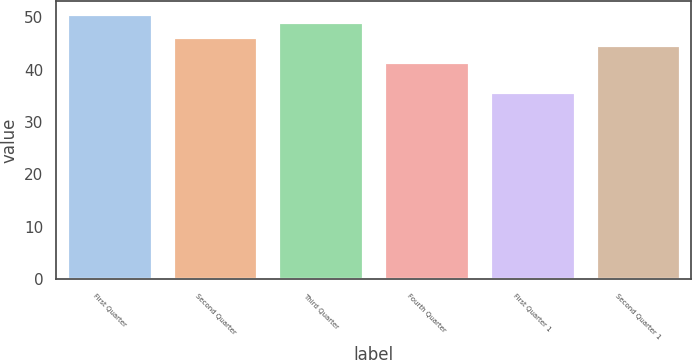Convert chart to OTSL. <chart><loc_0><loc_0><loc_500><loc_500><bar_chart><fcel>First Quarter<fcel>Second Quarter<fcel>Third Quarter<fcel>Fourth Quarter<fcel>First Quarter 1<fcel>Second Quarter 1<nl><fcel>50.54<fcel>46.15<fcel>49.13<fcel>41.43<fcel>35.76<fcel>44.74<nl></chart> 